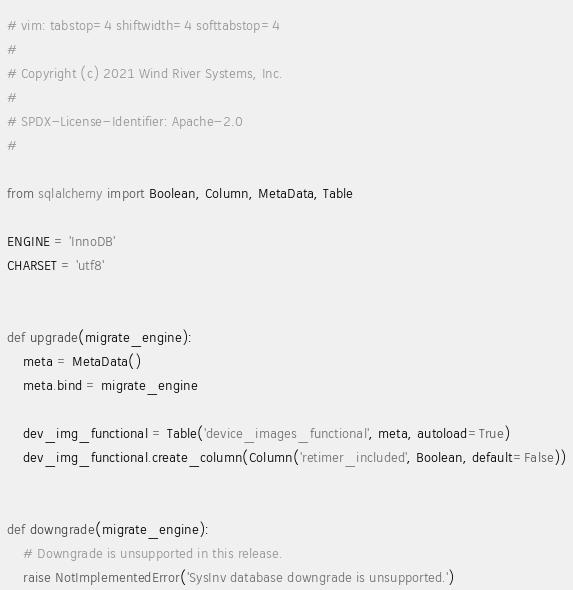Convert code to text. <code><loc_0><loc_0><loc_500><loc_500><_Python_># vim: tabstop=4 shiftwidth=4 softtabstop=4
#
# Copyright (c) 2021 Wind River Systems, Inc.
#
# SPDX-License-Identifier: Apache-2.0
#

from sqlalchemy import Boolean, Column, MetaData, Table

ENGINE = 'InnoDB'
CHARSET = 'utf8'


def upgrade(migrate_engine):
    meta = MetaData()
    meta.bind = migrate_engine

    dev_img_functional = Table('device_images_functional', meta, autoload=True)
    dev_img_functional.create_column(Column('retimer_included', Boolean, default=False))


def downgrade(migrate_engine):
    # Downgrade is unsupported in this release.
    raise NotImplementedError('SysInv database downgrade is unsupported.')
</code> 